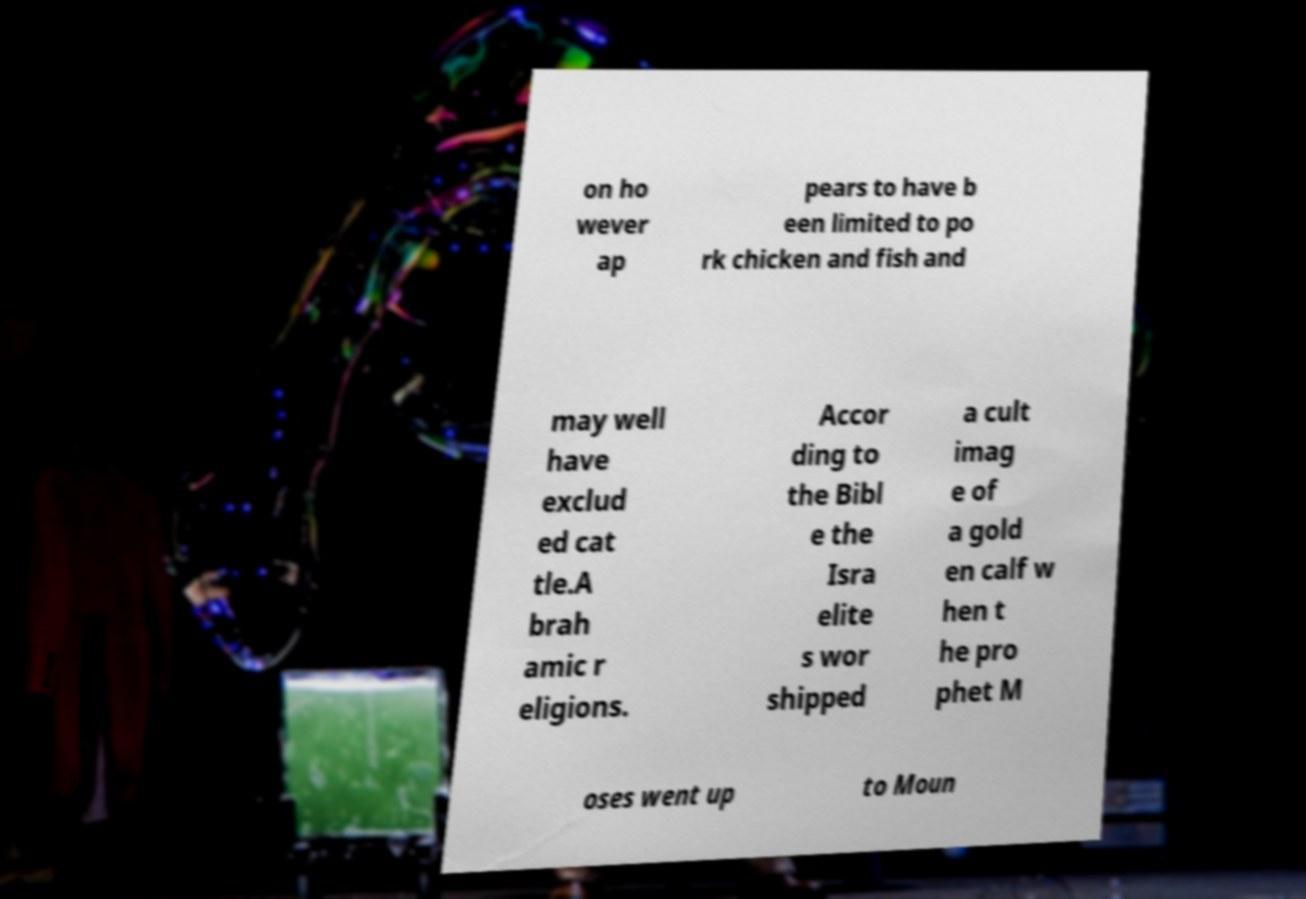Can you read and provide the text displayed in the image?This photo seems to have some interesting text. Can you extract and type it out for me? on ho wever ap pears to have b een limited to po rk chicken and fish and may well have exclud ed cat tle.A brah amic r eligions. Accor ding to the Bibl e the Isra elite s wor shipped a cult imag e of a gold en calf w hen t he pro phet M oses went up to Moun 